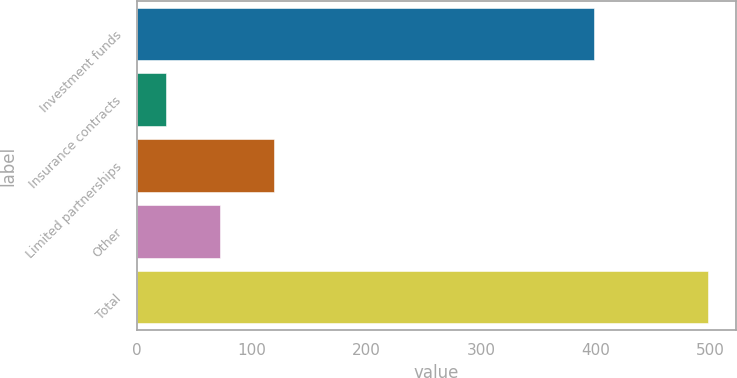Convert chart. <chart><loc_0><loc_0><loc_500><loc_500><bar_chart><fcel>Investment funds<fcel>Insurance contracts<fcel>Limited partnerships<fcel>Other<fcel>Total<nl><fcel>398.4<fcel>24.8<fcel>119.32<fcel>72.06<fcel>497.4<nl></chart> 